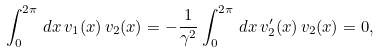Convert formula to latex. <formula><loc_0><loc_0><loc_500><loc_500>\int _ { 0 } ^ { 2 \pi } \, d x \, v _ { 1 } ( x ) \, v _ { 2 } ( x ) = - \frac { 1 } { \gamma ^ { 2 } } \int _ { 0 } ^ { 2 \pi } \, d x \, v _ { 2 } ^ { \prime } ( x ) \, v _ { 2 } ( x ) = 0 ,</formula> 